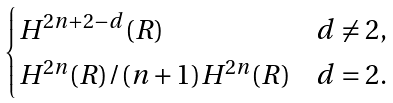<formula> <loc_0><loc_0><loc_500><loc_500>\begin{cases} H ^ { 2 n + 2 - d } ( R ) & d \neq 2 , \\ H ^ { 2 n } ( R ) / ( n + 1 ) H ^ { 2 n } ( R ) & d = 2 . \end{cases}</formula> 